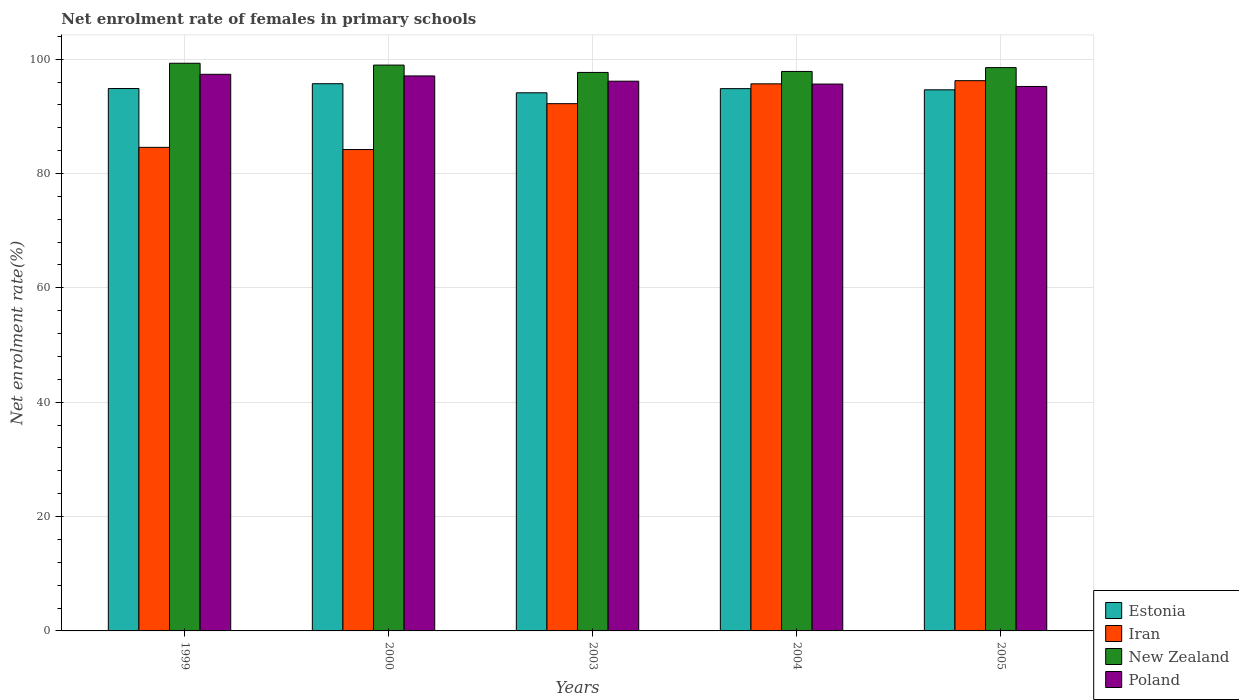How many different coloured bars are there?
Offer a terse response. 4. How many bars are there on the 3rd tick from the left?
Make the answer very short. 4. How many bars are there on the 2nd tick from the right?
Ensure brevity in your answer.  4. What is the label of the 1st group of bars from the left?
Your answer should be very brief. 1999. In how many cases, is the number of bars for a given year not equal to the number of legend labels?
Provide a short and direct response. 0. What is the net enrolment rate of females in primary schools in New Zealand in 2005?
Give a very brief answer. 98.52. Across all years, what is the maximum net enrolment rate of females in primary schools in Estonia?
Offer a terse response. 95.7. Across all years, what is the minimum net enrolment rate of females in primary schools in Iran?
Your response must be concise. 84.19. In which year was the net enrolment rate of females in primary schools in Iran minimum?
Make the answer very short. 2000. What is the total net enrolment rate of females in primary schools in New Zealand in the graph?
Offer a very short reply. 492.29. What is the difference between the net enrolment rate of females in primary schools in Poland in 1999 and that in 2000?
Provide a succinct answer. 0.28. What is the difference between the net enrolment rate of females in primary schools in Poland in 2000 and the net enrolment rate of females in primary schools in New Zealand in 2005?
Ensure brevity in your answer.  -1.45. What is the average net enrolment rate of females in primary schools in New Zealand per year?
Your answer should be very brief. 98.46. In the year 2004, what is the difference between the net enrolment rate of females in primary schools in Estonia and net enrolment rate of females in primary schools in Iran?
Make the answer very short. -0.84. What is the ratio of the net enrolment rate of females in primary schools in Estonia in 2003 to that in 2005?
Keep it short and to the point. 0.99. Is the net enrolment rate of females in primary schools in Poland in 2003 less than that in 2004?
Offer a terse response. No. Is the difference between the net enrolment rate of females in primary schools in Estonia in 2000 and 2004 greater than the difference between the net enrolment rate of females in primary schools in Iran in 2000 and 2004?
Keep it short and to the point. Yes. What is the difference between the highest and the second highest net enrolment rate of females in primary schools in Estonia?
Keep it short and to the point. 0.84. What is the difference between the highest and the lowest net enrolment rate of females in primary schools in Estonia?
Provide a short and direct response. 1.59. Is it the case that in every year, the sum of the net enrolment rate of females in primary schools in Iran and net enrolment rate of females in primary schools in Poland is greater than the sum of net enrolment rate of females in primary schools in Estonia and net enrolment rate of females in primary schools in New Zealand?
Your response must be concise. Yes. What does the 1st bar from the left in 2005 represents?
Ensure brevity in your answer.  Estonia. What does the 3rd bar from the right in 2004 represents?
Your answer should be very brief. Iran. Is it the case that in every year, the sum of the net enrolment rate of females in primary schools in New Zealand and net enrolment rate of females in primary schools in Poland is greater than the net enrolment rate of females in primary schools in Estonia?
Offer a very short reply. Yes. Are all the bars in the graph horizontal?
Your answer should be compact. No. How many years are there in the graph?
Offer a very short reply. 5. Does the graph contain any zero values?
Provide a short and direct response. No. How many legend labels are there?
Keep it short and to the point. 4. What is the title of the graph?
Provide a short and direct response. Net enrolment rate of females in primary schools. What is the label or title of the Y-axis?
Your answer should be very brief. Net enrolment rate(%). What is the Net enrolment rate(%) in Estonia in 1999?
Provide a succinct answer. 94.86. What is the Net enrolment rate(%) in Iran in 1999?
Offer a very short reply. 84.57. What is the Net enrolment rate(%) of New Zealand in 1999?
Offer a terse response. 99.28. What is the Net enrolment rate(%) in Poland in 1999?
Make the answer very short. 97.35. What is the Net enrolment rate(%) of Estonia in 2000?
Give a very brief answer. 95.7. What is the Net enrolment rate(%) in Iran in 2000?
Offer a very short reply. 84.19. What is the Net enrolment rate(%) of New Zealand in 2000?
Offer a very short reply. 98.96. What is the Net enrolment rate(%) of Poland in 2000?
Offer a very short reply. 97.06. What is the Net enrolment rate(%) of Estonia in 2003?
Offer a very short reply. 94.12. What is the Net enrolment rate(%) in Iran in 2003?
Provide a short and direct response. 92.21. What is the Net enrolment rate(%) in New Zealand in 2003?
Provide a succinct answer. 97.68. What is the Net enrolment rate(%) in Poland in 2003?
Offer a terse response. 96.14. What is the Net enrolment rate(%) in Estonia in 2004?
Ensure brevity in your answer.  94.84. What is the Net enrolment rate(%) of Iran in 2004?
Provide a succinct answer. 95.68. What is the Net enrolment rate(%) in New Zealand in 2004?
Ensure brevity in your answer.  97.85. What is the Net enrolment rate(%) in Poland in 2004?
Your response must be concise. 95.64. What is the Net enrolment rate(%) of Estonia in 2005?
Offer a very short reply. 94.64. What is the Net enrolment rate(%) in Iran in 2005?
Provide a short and direct response. 96.24. What is the Net enrolment rate(%) of New Zealand in 2005?
Keep it short and to the point. 98.52. What is the Net enrolment rate(%) in Poland in 2005?
Your answer should be very brief. 95.22. Across all years, what is the maximum Net enrolment rate(%) of Estonia?
Offer a terse response. 95.7. Across all years, what is the maximum Net enrolment rate(%) of Iran?
Offer a very short reply. 96.24. Across all years, what is the maximum Net enrolment rate(%) in New Zealand?
Ensure brevity in your answer.  99.28. Across all years, what is the maximum Net enrolment rate(%) in Poland?
Provide a succinct answer. 97.35. Across all years, what is the minimum Net enrolment rate(%) in Estonia?
Ensure brevity in your answer.  94.12. Across all years, what is the minimum Net enrolment rate(%) of Iran?
Your answer should be very brief. 84.19. Across all years, what is the minimum Net enrolment rate(%) of New Zealand?
Provide a succinct answer. 97.68. Across all years, what is the minimum Net enrolment rate(%) in Poland?
Your answer should be very brief. 95.22. What is the total Net enrolment rate(%) of Estonia in the graph?
Your response must be concise. 474.16. What is the total Net enrolment rate(%) of Iran in the graph?
Your answer should be compact. 452.9. What is the total Net enrolment rate(%) in New Zealand in the graph?
Your answer should be compact. 492.29. What is the total Net enrolment rate(%) of Poland in the graph?
Make the answer very short. 481.43. What is the difference between the Net enrolment rate(%) in Estonia in 1999 and that in 2000?
Your answer should be very brief. -0.84. What is the difference between the Net enrolment rate(%) of Iran in 1999 and that in 2000?
Provide a short and direct response. 0.38. What is the difference between the Net enrolment rate(%) in New Zealand in 1999 and that in 2000?
Your answer should be compact. 0.32. What is the difference between the Net enrolment rate(%) of Poland in 1999 and that in 2000?
Offer a terse response. 0.28. What is the difference between the Net enrolment rate(%) of Estonia in 1999 and that in 2003?
Offer a very short reply. 0.75. What is the difference between the Net enrolment rate(%) of Iran in 1999 and that in 2003?
Your answer should be compact. -7.64. What is the difference between the Net enrolment rate(%) of New Zealand in 1999 and that in 2003?
Your answer should be compact. 1.6. What is the difference between the Net enrolment rate(%) in Poland in 1999 and that in 2003?
Ensure brevity in your answer.  1.2. What is the difference between the Net enrolment rate(%) in Estonia in 1999 and that in 2004?
Your response must be concise. 0.02. What is the difference between the Net enrolment rate(%) of Iran in 1999 and that in 2004?
Keep it short and to the point. -11.11. What is the difference between the Net enrolment rate(%) of New Zealand in 1999 and that in 2004?
Offer a terse response. 1.43. What is the difference between the Net enrolment rate(%) of Poland in 1999 and that in 2004?
Provide a succinct answer. 1.71. What is the difference between the Net enrolment rate(%) of Estonia in 1999 and that in 2005?
Give a very brief answer. 0.23. What is the difference between the Net enrolment rate(%) in Iran in 1999 and that in 2005?
Ensure brevity in your answer.  -11.66. What is the difference between the Net enrolment rate(%) of New Zealand in 1999 and that in 2005?
Your answer should be compact. 0.76. What is the difference between the Net enrolment rate(%) in Poland in 1999 and that in 2005?
Provide a succinct answer. 2.13. What is the difference between the Net enrolment rate(%) of Estonia in 2000 and that in 2003?
Make the answer very short. 1.59. What is the difference between the Net enrolment rate(%) of Iran in 2000 and that in 2003?
Provide a succinct answer. -8.02. What is the difference between the Net enrolment rate(%) in New Zealand in 2000 and that in 2003?
Your answer should be very brief. 1.28. What is the difference between the Net enrolment rate(%) of Poland in 2000 and that in 2003?
Your answer should be very brief. 0.92. What is the difference between the Net enrolment rate(%) of Estonia in 2000 and that in 2004?
Ensure brevity in your answer.  0.86. What is the difference between the Net enrolment rate(%) in Iran in 2000 and that in 2004?
Provide a short and direct response. -11.49. What is the difference between the Net enrolment rate(%) of New Zealand in 2000 and that in 2004?
Provide a short and direct response. 1.11. What is the difference between the Net enrolment rate(%) of Poland in 2000 and that in 2004?
Make the answer very short. 1.42. What is the difference between the Net enrolment rate(%) of Estonia in 2000 and that in 2005?
Offer a terse response. 1.07. What is the difference between the Net enrolment rate(%) in Iran in 2000 and that in 2005?
Give a very brief answer. -12.05. What is the difference between the Net enrolment rate(%) in New Zealand in 2000 and that in 2005?
Provide a short and direct response. 0.44. What is the difference between the Net enrolment rate(%) in Poland in 2000 and that in 2005?
Provide a short and direct response. 1.84. What is the difference between the Net enrolment rate(%) of Estonia in 2003 and that in 2004?
Give a very brief answer. -0.73. What is the difference between the Net enrolment rate(%) of Iran in 2003 and that in 2004?
Give a very brief answer. -3.47. What is the difference between the Net enrolment rate(%) in New Zealand in 2003 and that in 2004?
Provide a short and direct response. -0.17. What is the difference between the Net enrolment rate(%) of Poland in 2003 and that in 2004?
Provide a short and direct response. 0.5. What is the difference between the Net enrolment rate(%) of Estonia in 2003 and that in 2005?
Offer a terse response. -0.52. What is the difference between the Net enrolment rate(%) of Iran in 2003 and that in 2005?
Your answer should be very brief. -4.02. What is the difference between the Net enrolment rate(%) of New Zealand in 2003 and that in 2005?
Your response must be concise. -0.84. What is the difference between the Net enrolment rate(%) of Poland in 2003 and that in 2005?
Your answer should be very brief. 0.92. What is the difference between the Net enrolment rate(%) of Estonia in 2004 and that in 2005?
Ensure brevity in your answer.  0.2. What is the difference between the Net enrolment rate(%) of Iran in 2004 and that in 2005?
Provide a short and direct response. -0.55. What is the difference between the Net enrolment rate(%) in New Zealand in 2004 and that in 2005?
Your answer should be very brief. -0.67. What is the difference between the Net enrolment rate(%) in Poland in 2004 and that in 2005?
Keep it short and to the point. 0.42. What is the difference between the Net enrolment rate(%) of Estonia in 1999 and the Net enrolment rate(%) of Iran in 2000?
Your answer should be very brief. 10.67. What is the difference between the Net enrolment rate(%) of Estonia in 1999 and the Net enrolment rate(%) of New Zealand in 2000?
Your answer should be very brief. -4.1. What is the difference between the Net enrolment rate(%) of Estonia in 1999 and the Net enrolment rate(%) of Poland in 2000?
Offer a terse response. -2.2. What is the difference between the Net enrolment rate(%) of Iran in 1999 and the Net enrolment rate(%) of New Zealand in 2000?
Offer a terse response. -14.39. What is the difference between the Net enrolment rate(%) in Iran in 1999 and the Net enrolment rate(%) in Poland in 2000?
Keep it short and to the point. -12.49. What is the difference between the Net enrolment rate(%) of New Zealand in 1999 and the Net enrolment rate(%) of Poland in 2000?
Offer a terse response. 2.22. What is the difference between the Net enrolment rate(%) in Estonia in 1999 and the Net enrolment rate(%) in Iran in 2003?
Your response must be concise. 2.65. What is the difference between the Net enrolment rate(%) in Estonia in 1999 and the Net enrolment rate(%) in New Zealand in 2003?
Your response must be concise. -2.81. What is the difference between the Net enrolment rate(%) of Estonia in 1999 and the Net enrolment rate(%) of Poland in 2003?
Give a very brief answer. -1.28. What is the difference between the Net enrolment rate(%) of Iran in 1999 and the Net enrolment rate(%) of New Zealand in 2003?
Offer a very short reply. -13.1. What is the difference between the Net enrolment rate(%) of Iran in 1999 and the Net enrolment rate(%) of Poland in 2003?
Make the answer very short. -11.57. What is the difference between the Net enrolment rate(%) in New Zealand in 1999 and the Net enrolment rate(%) in Poland in 2003?
Keep it short and to the point. 3.14. What is the difference between the Net enrolment rate(%) in Estonia in 1999 and the Net enrolment rate(%) in Iran in 2004?
Provide a succinct answer. -0.82. What is the difference between the Net enrolment rate(%) in Estonia in 1999 and the Net enrolment rate(%) in New Zealand in 2004?
Provide a succinct answer. -2.99. What is the difference between the Net enrolment rate(%) in Estonia in 1999 and the Net enrolment rate(%) in Poland in 2004?
Give a very brief answer. -0.78. What is the difference between the Net enrolment rate(%) in Iran in 1999 and the Net enrolment rate(%) in New Zealand in 2004?
Offer a very short reply. -13.28. What is the difference between the Net enrolment rate(%) of Iran in 1999 and the Net enrolment rate(%) of Poland in 2004?
Give a very brief answer. -11.07. What is the difference between the Net enrolment rate(%) in New Zealand in 1999 and the Net enrolment rate(%) in Poland in 2004?
Offer a terse response. 3.64. What is the difference between the Net enrolment rate(%) in Estonia in 1999 and the Net enrolment rate(%) in Iran in 2005?
Keep it short and to the point. -1.37. What is the difference between the Net enrolment rate(%) in Estonia in 1999 and the Net enrolment rate(%) in New Zealand in 2005?
Offer a terse response. -3.65. What is the difference between the Net enrolment rate(%) in Estonia in 1999 and the Net enrolment rate(%) in Poland in 2005?
Ensure brevity in your answer.  -0.36. What is the difference between the Net enrolment rate(%) in Iran in 1999 and the Net enrolment rate(%) in New Zealand in 2005?
Your response must be concise. -13.94. What is the difference between the Net enrolment rate(%) of Iran in 1999 and the Net enrolment rate(%) of Poland in 2005?
Provide a short and direct response. -10.65. What is the difference between the Net enrolment rate(%) of New Zealand in 1999 and the Net enrolment rate(%) of Poland in 2005?
Your answer should be compact. 4.06. What is the difference between the Net enrolment rate(%) of Estonia in 2000 and the Net enrolment rate(%) of Iran in 2003?
Provide a short and direct response. 3.49. What is the difference between the Net enrolment rate(%) in Estonia in 2000 and the Net enrolment rate(%) in New Zealand in 2003?
Keep it short and to the point. -1.98. What is the difference between the Net enrolment rate(%) in Estonia in 2000 and the Net enrolment rate(%) in Poland in 2003?
Give a very brief answer. -0.44. What is the difference between the Net enrolment rate(%) in Iran in 2000 and the Net enrolment rate(%) in New Zealand in 2003?
Ensure brevity in your answer.  -13.49. What is the difference between the Net enrolment rate(%) in Iran in 2000 and the Net enrolment rate(%) in Poland in 2003?
Offer a terse response. -11.95. What is the difference between the Net enrolment rate(%) of New Zealand in 2000 and the Net enrolment rate(%) of Poland in 2003?
Offer a very short reply. 2.82. What is the difference between the Net enrolment rate(%) of Estonia in 2000 and the Net enrolment rate(%) of Iran in 2004?
Offer a terse response. 0.02. What is the difference between the Net enrolment rate(%) in Estonia in 2000 and the Net enrolment rate(%) in New Zealand in 2004?
Provide a succinct answer. -2.15. What is the difference between the Net enrolment rate(%) of Estonia in 2000 and the Net enrolment rate(%) of Poland in 2004?
Your answer should be very brief. 0.06. What is the difference between the Net enrolment rate(%) in Iran in 2000 and the Net enrolment rate(%) in New Zealand in 2004?
Provide a succinct answer. -13.66. What is the difference between the Net enrolment rate(%) in Iran in 2000 and the Net enrolment rate(%) in Poland in 2004?
Make the answer very short. -11.45. What is the difference between the Net enrolment rate(%) in New Zealand in 2000 and the Net enrolment rate(%) in Poland in 2004?
Your answer should be compact. 3.32. What is the difference between the Net enrolment rate(%) of Estonia in 2000 and the Net enrolment rate(%) of Iran in 2005?
Your response must be concise. -0.53. What is the difference between the Net enrolment rate(%) of Estonia in 2000 and the Net enrolment rate(%) of New Zealand in 2005?
Offer a terse response. -2.82. What is the difference between the Net enrolment rate(%) in Estonia in 2000 and the Net enrolment rate(%) in Poland in 2005?
Provide a succinct answer. 0.48. What is the difference between the Net enrolment rate(%) of Iran in 2000 and the Net enrolment rate(%) of New Zealand in 2005?
Your answer should be compact. -14.33. What is the difference between the Net enrolment rate(%) of Iran in 2000 and the Net enrolment rate(%) of Poland in 2005?
Provide a short and direct response. -11.03. What is the difference between the Net enrolment rate(%) in New Zealand in 2000 and the Net enrolment rate(%) in Poland in 2005?
Offer a terse response. 3.74. What is the difference between the Net enrolment rate(%) in Estonia in 2003 and the Net enrolment rate(%) in Iran in 2004?
Make the answer very short. -1.57. What is the difference between the Net enrolment rate(%) in Estonia in 2003 and the Net enrolment rate(%) in New Zealand in 2004?
Keep it short and to the point. -3.73. What is the difference between the Net enrolment rate(%) in Estonia in 2003 and the Net enrolment rate(%) in Poland in 2004?
Provide a succinct answer. -1.53. What is the difference between the Net enrolment rate(%) of Iran in 2003 and the Net enrolment rate(%) of New Zealand in 2004?
Offer a very short reply. -5.64. What is the difference between the Net enrolment rate(%) in Iran in 2003 and the Net enrolment rate(%) in Poland in 2004?
Your answer should be very brief. -3.43. What is the difference between the Net enrolment rate(%) in New Zealand in 2003 and the Net enrolment rate(%) in Poland in 2004?
Ensure brevity in your answer.  2.04. What is the difference between the Net enrolment rate(%) of Estonia in 2003 and the Net enrolment rate(%) of Iran in 2005?
Give a very brief answer. -2.12. What is the difference between the Net enrolment rate(%) of Estonia in 2003 and the Net enrolment rate(%) of New Zealand in 2005?
Your answer should be compact. -4.4. What is the difference between the Net enrolment rate(%) of Estonia in 2003 and the Net enrolment rate(%) of Poland in 2005?
Your response must be concise. -1.11. What is the difference between the Net enrolment rate(%) of Iran in 2003 and the Net enrolment rate(%) of New Zealand in 2005?
Ensure brevity in your answer.  -6.3. What is the difference between the Net enrolment rate(%) of Iran in 2003 and the Net enrolment rate(%) of Poland in 2005?
Your response must be concise. -3.01. What is the difference between the Net enrolment rate(%) of New Zealand in 2003 and the Net enrolment rate(%) of Poland in 2005?
Your answer should be compact. 2.46. What is the difference between the Net enrolment rate(%) of Estonia in 2004 and the Net enrolment rate(%) of Iran in 2005?
Give a very brief answer. -1.4. What is the difference between the Net enrolment rate(%) in Estonia in 2004 and the Net enrolment rate(%) in New Zealand in 2005?
Provide a succinct answer. -3.68. What is the difference between the Net enrolment rate(%) in Estonia in 2004 and the Net enrolment rate(%) in Poland in 2005?
Your answer should be compact. -0.38. What is the difference between the Net enrolment rate(%) of Iran in 2004 and the Net enrolment rate(%) of New Zealand in 2005?
Provide a succinct answer. -2.83. What is the difference between the Net enrolment rate(%) of Iran in 2004 and the Net enrolment rate(%) of Poland in 2005?
Offer a very short reply. 0.46. What is the difference between the Net enrolment rate(%) in New Zealand in 2004 and the Net enrolment rate(%) in Poland in 2005?
Your answer should be very brief. 2.63. What is the average Net enrolment rate(%) of Estonia per year?
Your response must be concise. 94.83. What is the average Net enrolment rate(%) of Iran per year?
Provide a short and direct response. 90.58. What is the average Net enrolment rate(%) of New Zealand per year?
Provide a short and direct response. 98.46. What is the average Net enrolment rate(%) in Poland per year?
Provide a succinct answer. 96.29. In the year 1999, what is the difference between the Net enrolment rate(%) of Estonia and Net enrolment rate(%) of Iran?
Provide a succinct answer. 10.29. In the year 1999, what is the difference between the Net enrolment rate(%) of Estonia and Net enrolment rate(%) of New Zealand?
Your answer should be compact. -4.42. In the year 1999, what is the difference between the Net enrolment rate(%) in Estonia and Net enrolment rate(%) in Poland?
Make the answer very short. -2.49. In the year 1999, what is the difference between the Net enrolment rate(%) in Iran and Net enrolment rate(%) in New Zealand?
Your answer should be compact. -14.71. In the year 1999, what is the difference between the Net enrolment rate(%) of Iran and Net enrolment rate(%) of Poland?
Ensure brevity in your answer.  -12.77. In the year 1999, what is the difference between the Net enrolment rate(%) of New Zealand and Net enrolment rate(%) of Poland?
Your answer should be compact. 1.93. In the year 2000, what is the difference between the Net enrolment rate(%) in Estonia and Net enrolment rate(%) in Iran?
Provide a short and direct response. 11.51. In the year 2000, what is the difference between the Net enrolment rate(%) of Estonia and Net enrolment rate(%) of New Zealand?
Make the answer very short. -3.26. In the year 2000, what is the difference between the Net enrolment rate(%) in Estonia and Net enrolment rate(%) in Poland?
Provide a succinct answer. -1.36. In the year 2000, what is the difference between the Net enrolment rate(%) of Iran and Net enrolment rate(%) of New Zealand?
Ensure brevity in your answer.  -14.77. In the year 2000, what is the difference between the Net enrolment rate(%) of Iran and Net enrolment rate(%) of Poland?
Offer a terse response. -12.87. In the year 2000, what is the difference between the Net enrolment rate(%) in New Zealand and Net enrolment rate(%) in Poland?
Ensure brevity in your answer.  1.9. In the year 2003, what is the difference between the Net enrolment rate(%) of Estonia and Net enrolment rate(%) of Iran?
Offer a very short reply. 1.9. In the year 2003, what is the difference between the Net enrolment rate(%) in Estonia and Net enrolment rate(%) in New Zealand?
Offer a terse response. -3.56. In the year 2003, what is the difference between the Net enrolment rate(%) of Estonia and Net enrolment rate(%) of Poland?
Offer a very short reply. -2.03. In the year 2003, what is the difference between the Net enrolment rate(%) in Iran and Net enrolment rate(%) in New Zealand?
Offer a very short reply. -5.46. In the year 2003, what is the difference between the Net enrolment rate(%) in Iran and Net enrolment rate(%) in Poland?
Offer a very short reply. -3.93. In the year 2003, what is the difference between the Net enrolment rate(%) in New Zealand and Net enrolment rate(%) in Poland?
Offer a very short reply. 1.53. In the year 2004, what is the difference between the Net enrolment rate(%) of Estonia and Net enrolment rate(%) of Iran?
Make the answer very short. -0.84. In the year 2004, what is the difference between the Net enrolment rate(%) of Estonia and Net enrolment rate(%) of New Zealand?
Provide a short and direct response. -3.01. In the year 2004, what is the difference between the Net enrolment rate(%) of Estonia and Net enrolment rate(%) of Poland?
Make the answer very short. -0.8. In the year 2004, what is the difference between the Net enrolment rate(%) of Iran and Net enrolment rate(%) of New Zealand?
Your answer should be very brief. -2.17. In the year 2004, what is the difference between the Net enrolment rate(%) of Iran and Net enrolment rate(%) of Poland?
Your answer should be compact. 0.04. In the year 2004, what is the difference between the Net enrolment rate(%) in New Zealand and Net enrolment rate(%) in Poland?
Provide a short and direct response. 2.21. In the year 2005, what is the difference between the Net enrolment rate(%) in Estonia and Net enrolment rate(%) in New Zealand?
Provide a succinct answer. -3.88. In the year 2005, what is the difference between the Net enrolment rate(%) of Estonia and Net enrolment rate(%) of Poland?
Offer a very short reply. -0.59. In the year 2005, what is the difference between the Net enrolment rate(%) of Iran and Net enrolment rate(%) of New Zealand?
Your answer should be very brief. -2.28. In the year 2005, what is the difference between the Net enrolment rate(%) of Iran and Net enrolment rate(%) of Poland?
Provide a short and direct response. 1.01. In the year 2005, what is the difference between the Net enrolment rate(%) of New Zealand and Net enrolment rate(%) of Poland?
Offer a terse response. 3.3. What is the ratio of the Net enrolment rate(%) of Estonia in 1999 to that in 2000?
Offer a very short reply. 0.99. What is the ratio of the Net enrolment rate(%) of Iran in 1999 to that in 2000?
Keep it short and to the point. 1. What is the ratio of the Net enrolment rate(%) in Estonia in 1999 to that in 2003?
Your answer should be very brief. 1.01. What is the ratio of the Net enrolment rate(%) in Iran in 1999 to that in 2003?
Offer a terse response. 0.92. What is the ratio of the Net enrolment rate(%) of New Zealand in 1999 to that in 2003?
Your answer should be compact. 1.02. What is the ratio of the Net enrolment rate(%) of Poland in 1999 to that in 2003?
Your answer should be compact. 1.01. What is the ratio of the Net enrolment rate(%) of Estonia in 1999 to that in 2004?
Offer a very short reply. 1. What is the ratio of the Net enrolment rate(%) in Iran in 1999 to that in 2004?
Give a very brief answer. 0.88. What is the ratio of the Net enrolment rate(%) of New Zealand in 1999 to that in 2004?
Your response must be concise. 1.01. What is the ratio of the Net enrolment rate(%) in Poland in 1999 to that in 2004?
Provide a succinct answer. 1.02. What is the ratio of the Net enrolment rate(%) of Iran in 1999 to that in 2005?
Offer a very short reply. 0.88. What is the ratio of the Net enrolment rate(%) of New Zealand in 1999 to that in 2005?
Give a very brief answer. 1.01. What is the ratio of the Net enrolment rate(%) in Poland in 1999 to that in 2005?
Provide a short and direct response. 1.02. What is the ratio of the Net enrolment rate(%) of Estonia in 2000 to that in 2003?
Provide a short and direct response. 1.02. What is the ratio of the Net enrolment rate(%) of Iran in 2000 to that in 2003?
Provide a short and direct response. 0.91. What is the ratio of the Net enrolment rate(%) of New Zealand in 2000 to that in 2003?
Your response must be concise. 1.01. What is the ratio of the Net enrolment rate(%) of Poland in 2000 to that in 2003?
Your answer should be compact. 1.01. What is the ratio of the Net enrolment rate(%) of Estonia in 2000 to that in 2004?
Provide a succinct answer. 1.01. What is the ratio of the Net enrolment rate(%) of Iran in 2000 to that in 2004?
Make the answer very short. 0.88. What is the ratio of the Net enrolment rate(%) in New Zealand in 2000 to that in 2004?
Provide a short and direct response. 1.01. What is the ratio of the Net enrolment rate(%) in Poland in 2000 to that in 2004?
Your answer should be compact. 1.01. What is the ratio of the Net enrolment rate(%) of Estonia in 2000 to that in 2005?
Your response must be concise. 1.01. What is the ratio of the Net enrolment rate(%) in Iran in 2000 to that in 2005?
Give a very brief answer. 0.87. What is the ratio of the Net enrolment rate(%) in New Zealand in 2000 to that in 2005?
Provide a succinct answer. 1. What is the ratio of the Net enrolment rate(%) of Poland in 2000 to that in 2005?
Your response must be concise. 1.02. What is the ratio of the Net enrolment rate(%) in Estonia in 2003 to that in 2004?
Ensure brevity in your answer.  0.99. What is the ratio of the Net enrolment rate(%) of Iran in 2003 to that in 2004?
Offer a very short reply. 0.96. What is the ratio of the Net enrolment rate(%) in New Zealand in 2003 to that in 2004?
Your answer should be very brief. 1. What is the ratio of the Net enrolment rate(%) in Poland in 2003 to that in 2004?
Offer a very short reply. 1.01. What is the ratio of the Net enrolment rate(%) of Estonia in 2003 to that in 2005?
Make the answer very short. 0.99. What is the ratio of the Net enrolment rate(%) in Iran in 2003 to that in 2005?
Your response must be concise. 0.96. What is the ratio of the Net enrolment rate(%) in Poland in 2003 to that in 2005?
Ensure brevity in your answer.  1.01. What is the ratio of the Net enrolment rate(%) of Iran in 2004 to that in 2005?
Keep it short and to the point. 0.99. What is the difference between the highest and the second highest Net enrolment rate(%) of Estonia?
Provide a short and direct response. 0.84. What is the difference between the highest and the second highest Net enrolment rate(%) in Iran?
Your answer should be very brief. 0.55. What is the difference between the highest and the second highest Net enrolment rate(%) in New Zealand?
Give a very brief answer. 0.32. What is the difference between the highest and the second highest Net enrolment rate(%) in Poland?
Give a very brief answer. 0.28. What is the difference between the highest and the lowest Net enrolment rate(%) in Estonia?
Ensure brevity in your answer.  1.59. What is the difference between the highest and the lowest Net enrolment rate(%) of Iran?
Your response must be concise. 12.05. What is the difference between the highest and the lowest Net enrolment rate(%) of New Zealand?
Offer a very short reply. 1.6. What is the difference between the highest and the lowest Net enrolment rate(%) in Poland?
Provide a succinct answer. 2.13. 